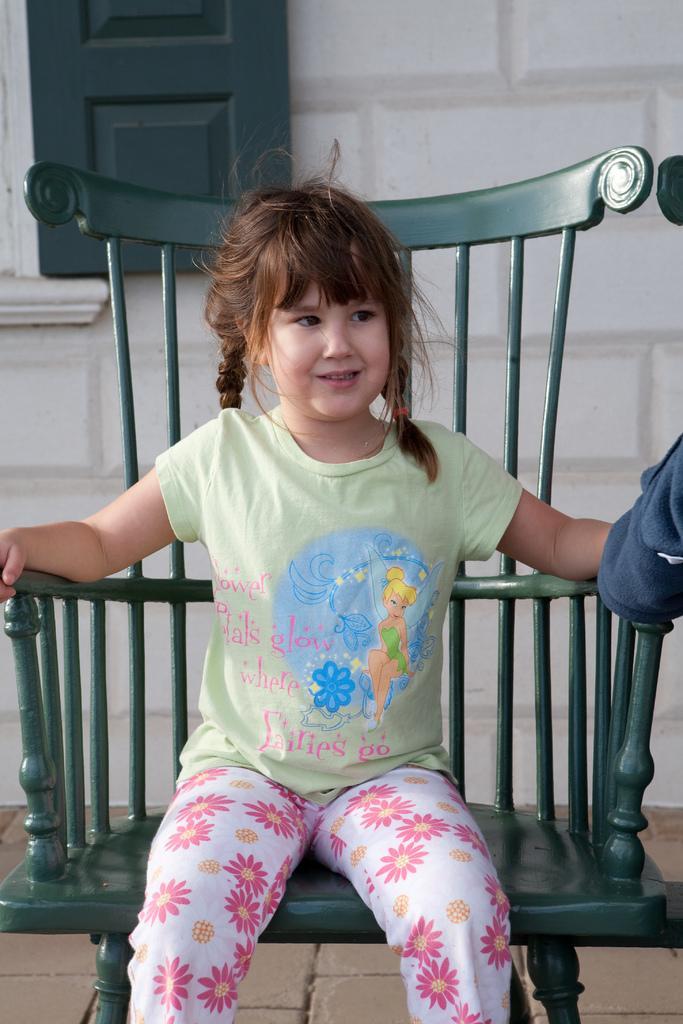Can you describe this image briefly? Middle of the center she is sitting on a chair. She is wearing a colorful dress. We can see in background white color wall and window. 